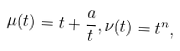Convert formula to latex. <formula><loc_0><loc_0><loc_500><loc_500>\mu ( t ) = t + \frac { a } { t } , \nu ( t ) = t ^ { n } ,</formula> 